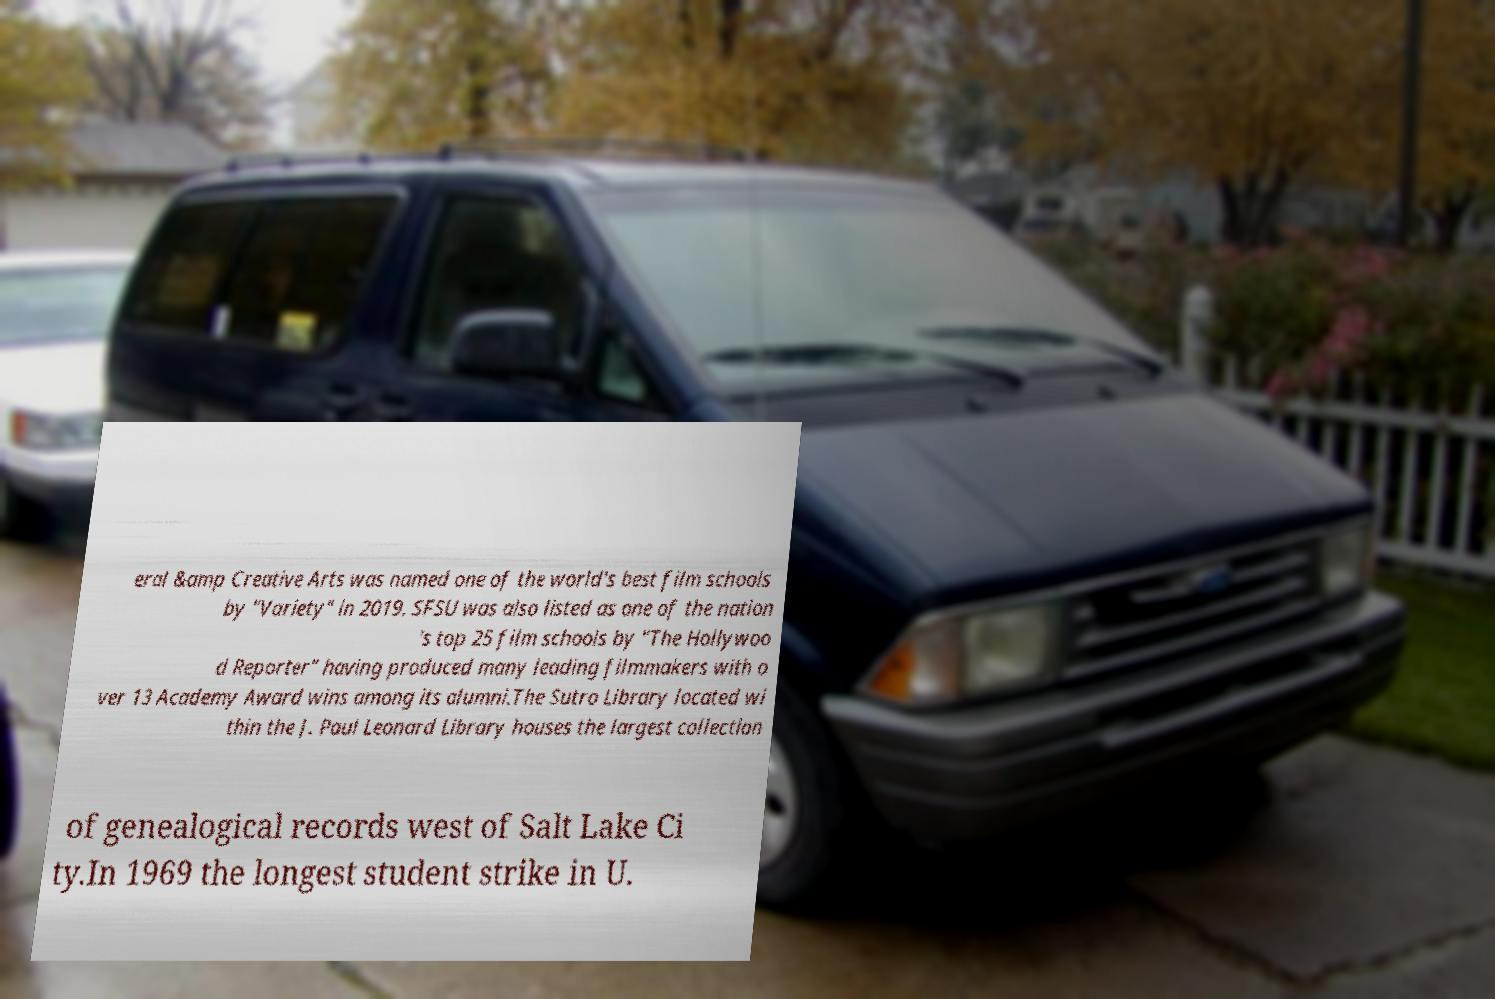Can you accurately transcribe the text from the provided image for me? eral &amp Creative Arts was named one of the world's best film schools by "Variety" in 2019. SFSU was also listed as one of the nation 's top 25 film schools by "The Hollywoo d Reporter" having produced many leading filmmakers with o ver 13 Academy Award wins among its alumni.The Sutro Library located wi thin the J. Paul Leonard Library houses the largest collection of genealogical records west of Salt Lake Ci ty.In 1969 the longest student strike in U. 